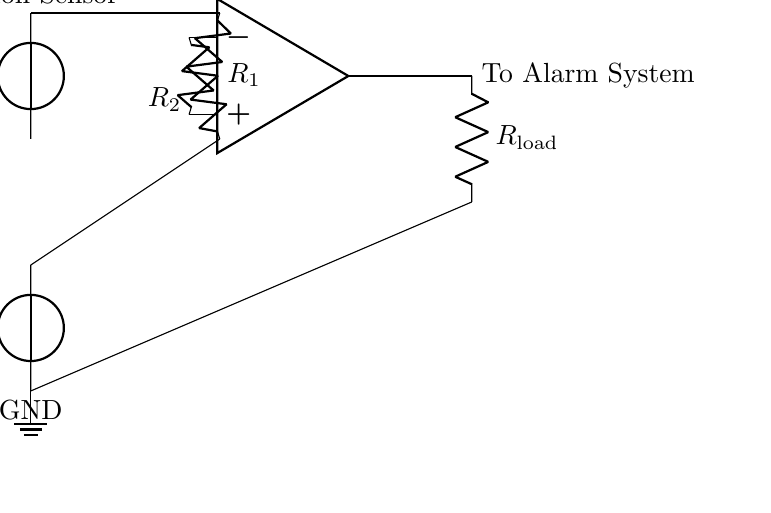What is the type of the main component in the circuit? The main component is an operational amplifier, which is indicated by the symbol in the middle of the diagram.
Answer: operational amplifier What does the motion sensor supply to the circuit? The motion sensor supplies the voltage represented as V sensor, which indicates the signal detected by the sensor and provides input to the op-amp.
Answer: V sensor What are the resistances labeled in the circuit? The resistances are labeled as R one and R two for the resistors connected to the positive and negative terminals of the op-amp respectively.
Answer: R one, R two What happens when V sensor is greater than V ref? When V sensor exceeds V ref, the output of the op-amp changes state, likely activating the alarm system as indicated by "To Alarm System".
Answer: Activates alarm What is the role of R load in this circuit? R load serves as a load resistor, which could limit the current flowing to the alarm system and protect it from potential damage due to excessive current.
Answer: Limit current How many voltage sources are present in the circuit? There are two voltage sources in the circuit: one for the motion sensor, V sensor, and one for the reference voltage, V ref.
Answer: two What is the reference voltage given in the circuit? The reference voltage is represented as V ref, which is applied to the negative terminal of the op-amp and is compared against V sensor.
Answer: V ref 